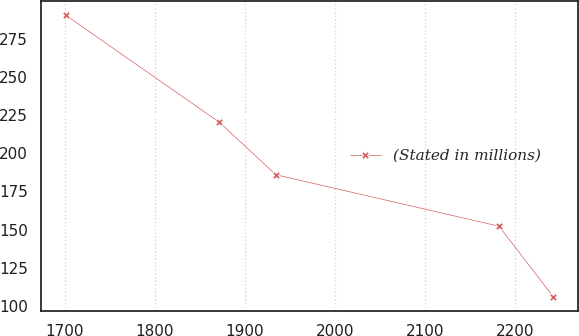Convert chart. <chart><loc_0><loc_0><loc_500><loc_500><line_chart><ecel><fcel>(Stated in millions)<nl><fcel>1701.19<fcel>290.44<nl><fcel>1871.95<fcel>220.27<nl><fcel>1934.52<fcel>185.95<nl><fcel>2182.41<fcel>152.23<nl><fcel>2242.62<fcel>106.04<nl></chart> 